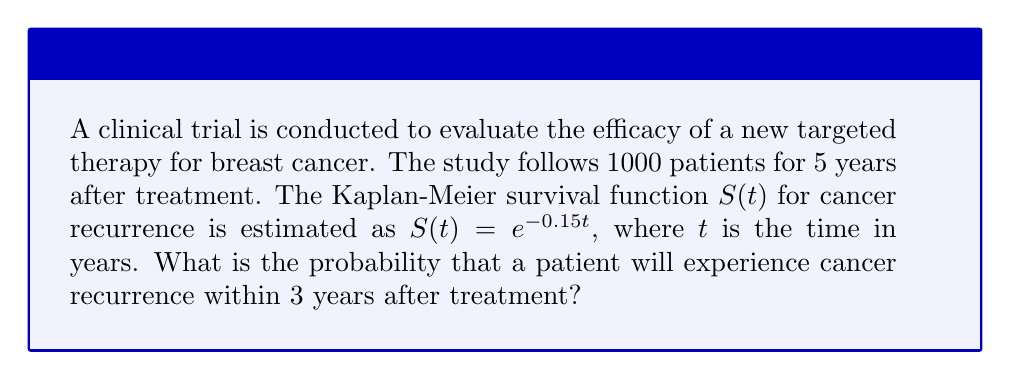Help me with this question. To solve this problem, we'll use the survival function $S(t)$ and follow these steps:

1. Understand the survival function:
   $S(t) = e^{-0.15t}$, where $t$ is time in years

2. The probability of recurrence within 3 years is the complement of the probability of survival without recurrence for 3 years:
   $P(\text{recurrence within 3 years}) = 1 - P(\text{survival without recurrence for 3 years})$

3. Calculate the probability of survival without recurrence for 3 years:
   $P(\text{survival without recurrence for 3 years}) = S(3) = e^{-0.15 \cdot 3}$

4. Compute the exponential term:
   $e^{-0.15 \cdot 3} = e^{-0.45} \approx 0.6376$

5. Calculate the probability of recurrence within 3 years:
   $P(\text{recurrence within 3 years}) = 1 - S(3) = 1 - 0.6376 \approx 0.3624$

6. Convert to percentage:
   $0.3624 \cdot 100\% = 36.24\%$
Answer: 36.24% 